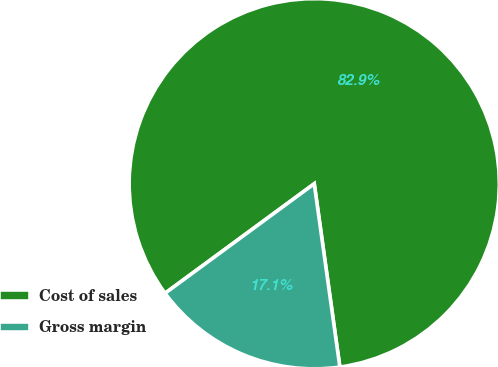<chart> <loc_0><loc_0><loc_500><loc_500><pie_chart><fcel>Cost of sales<fcel>Gross margin<nl><fcel>82.87%<fcel>17.13%<nl></chart> 